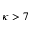Convert formula to latex. <formula><loc_0><loc_0><loc_500><loc_500>\kappa > 7</formula> 